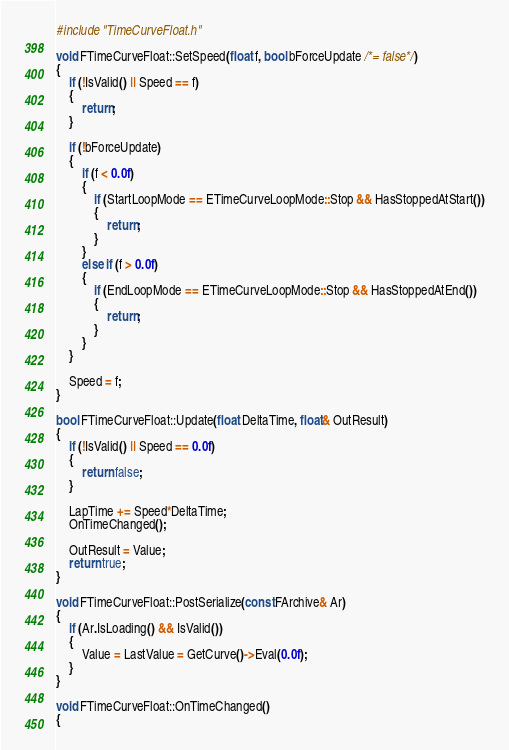<code> <loc_0><loc_0><loc_500><loc_500><_C++_>#include "TimeCurveFloat.h"

void FTimeCurveFloat::SetSpeed(float f, bool bForceUpdate /*= false*/)
{
	if (!IsValid() || Speed == f)
	{
		return;
	}

	if (!bForceUpdate)
	{
		if (f < 0.0f)
		{
			if (StartLoopMode == ETimeCurveLoopMode::Stop && HasStoppedAtStart())
			{
				return;
			}
		}
		else if (f > 0.0f)
		{
			if (EndLoopMode == ETimeCurveLoopMode::Stop && HasStoppedAtEnd())
			{
				return;
			}
		}
	}

	Speed = f;
}

bool FTimeCurveFloat::Update(float DeltaTime, float& OutResult)
{
	if (!IsValid() || Speed == 0.0f)
	{
		return false;
	}

	LapTime += Speed*DeltaTime;
	OnTimeChanged();

	OutResult = Value;
	return true;
}

void FTimeCurveFloat::PostSerialize(const FArchive& Ar)
{
	if (Ar.IsLoading() && IsValid())
	{
		Value = LastValue = GetCurve()->Eval(0.0f);
	}
}

void FTimeCurveFloat::OnTimeChanged()
{</code> 